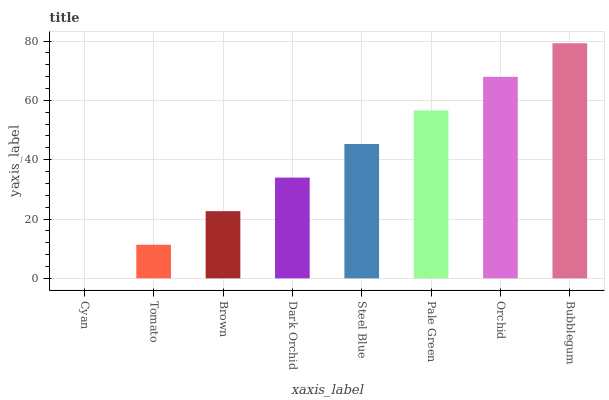Is Cyan the minimum?
Answer yes or no. Yes. Is Bubblegum the maximum?
Answer yes or no. Yes. Is Tomato the minimum?
Answer yes or no. No. Is Tomato the maximum?
Answer yes or no. No. Is Tomato greater than Cyan?
Answer yes or no. Yes. Is Cyan less than Tomato?
Answer yes or no. Yes. Is Cyan greater than Tomato?
Answer yes or no. No. Is Tomato less than Cyan?
Answer yes or no. No. Is Steel Blue the high median?
Answer yes or no. Yes. Is Dark Orchid the low median?
Answer yes or no. Yes. Is Orchid the high median?
Answer yes or no. No. Is Bubblegum the low median?
Answer yes or no. No. 